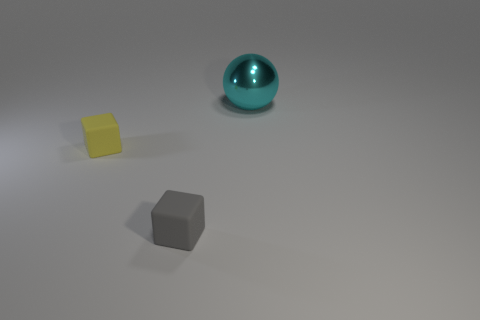Could you describe the lighting in the scene? Certainly, the lighting in the scene appears soft and diffused, casting gentle shadows and highlights on the objects without creating harsh contrasts. The direction of light seems to be coming from the upper left side, as indicated by the positioning of the shadows. This type of lighting suggests an indoor setting with controlled lighting conditions, perhaps intended to mimic natural light. 